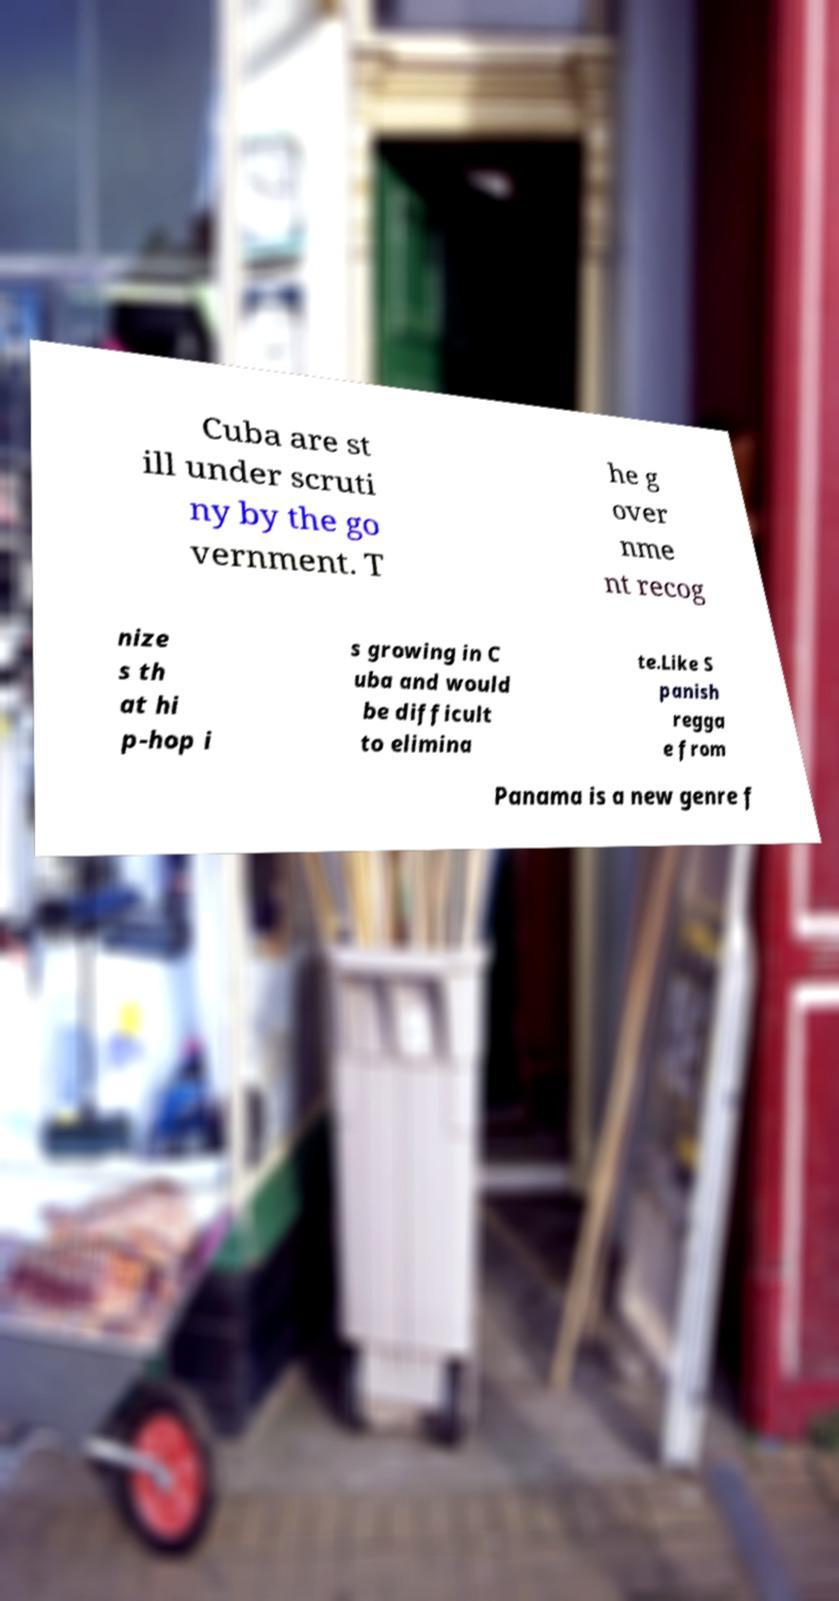What messages or text are displayed in this image? I need them in a readable, typed format. Cuba are st ill under scruti ny by the go vernment. T he g over nme nt recog nize s th at hi p-hop i s growing in C uba and would be difficult to elimina te.Like S panish regga e from Panama is a new genre f 